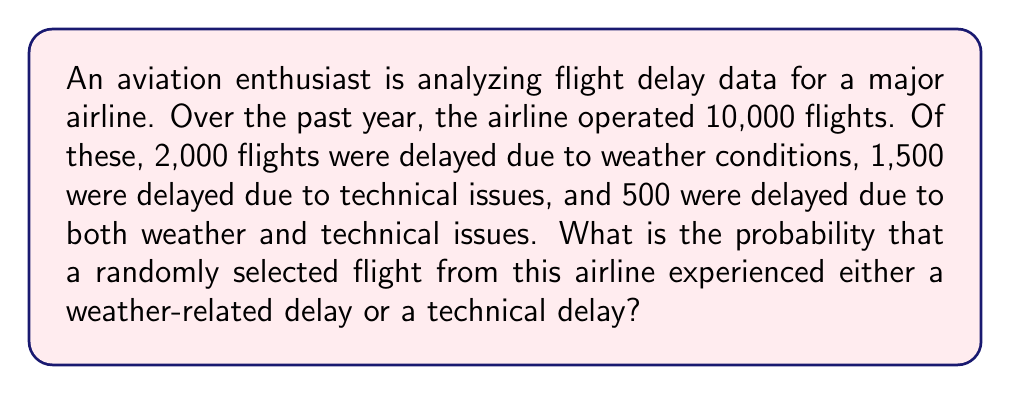What is the answer to this math problem? To solve this problem, we can use the concept of probability and set theory. Let's break it down step by step:

1. Define our sets:
   Let W be the set of flights delayed due to weather
   Let T be the set of flights delayed due to technical issues

2. Given information:
   Total flights: 10,000
   $|W| = 2,000$ (number of flights delayed due to weather)
   $|T| = 1,500$ (number of flights delayed due to technical issues)
   $|W \cap T| = 500$ (number of flights delayed due to both weather and technical issues)

3. We need to find $P(W \cup T)$, the probability of a flight being delayed due to weather OR technical issues.

4. Using the addition rule of probability:
   $$P(W \cup T) = P(W) + P(T) - P(W \cap T)$$

5. Calculate each probability:
   $P(W) = \frac{|W|}{Total flights} = \frac{2,000}{10,000} = 0.2$
   $P(T) = \frac{|T|}{Total flights} = \frac{1,500}{10,000} = 0.15$
   $P(W \cap T) = \frac{|W \cap T|}{Total flights} = \frac{500}{10,000} = 0.05$

6. Substitute these values into the formula:
   $$P(W \cup T) = 0.2 + 0.15 - 0.05 = 0.3$$

7. Convert to a percentage:
   $0.3 \times 100\% = 30\%$

Therefore, the probability that a randomly selected flight experienced either a weather-related delay or a technical delay is 30%.
Answer: 30% 